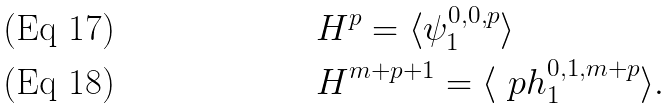Convert formula to latex. <formula><loc_0><loc_0><loc_500><loc_500>& H ^ { p } = \langle \psi ^ { 0 , 0 , p } _ { 1 } \rangle \\ & H ^ { m + p + 1 } = \langle \ p h ^ { 0 , 1 , m + p } _ { 1 } \rangle .</formula> 